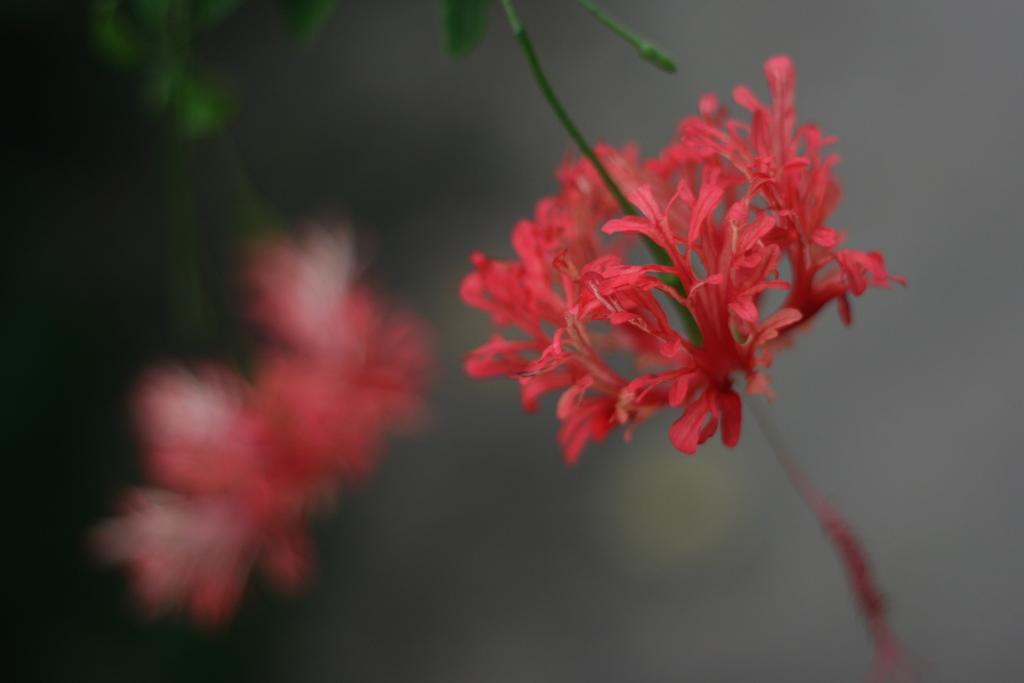How would you summarize this image in a sentence or two? In this image there is a red color flower to a plant having a bud and leaves to it. Left side there is a flower of a plant. 